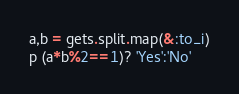Convert code to text. <code><loc_0><loc_0><loc_500><loc_500><_Ruby_>a,b = gets.split.map(&:to_i)
p (a*b%2==1)? 'Yes':'No'</code> 